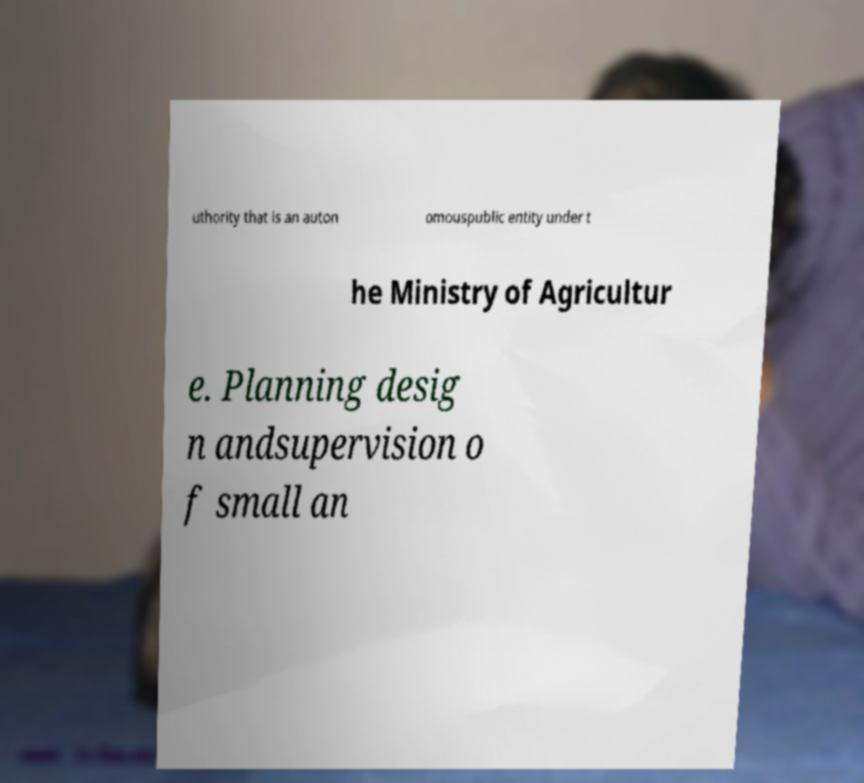What messages or text are displayed in this image? I need them in a readable, typed format. uthority that is an auton omouspublic entity under t he Ministry of Agricultur e. Planning desig n andsupervision o f small an 